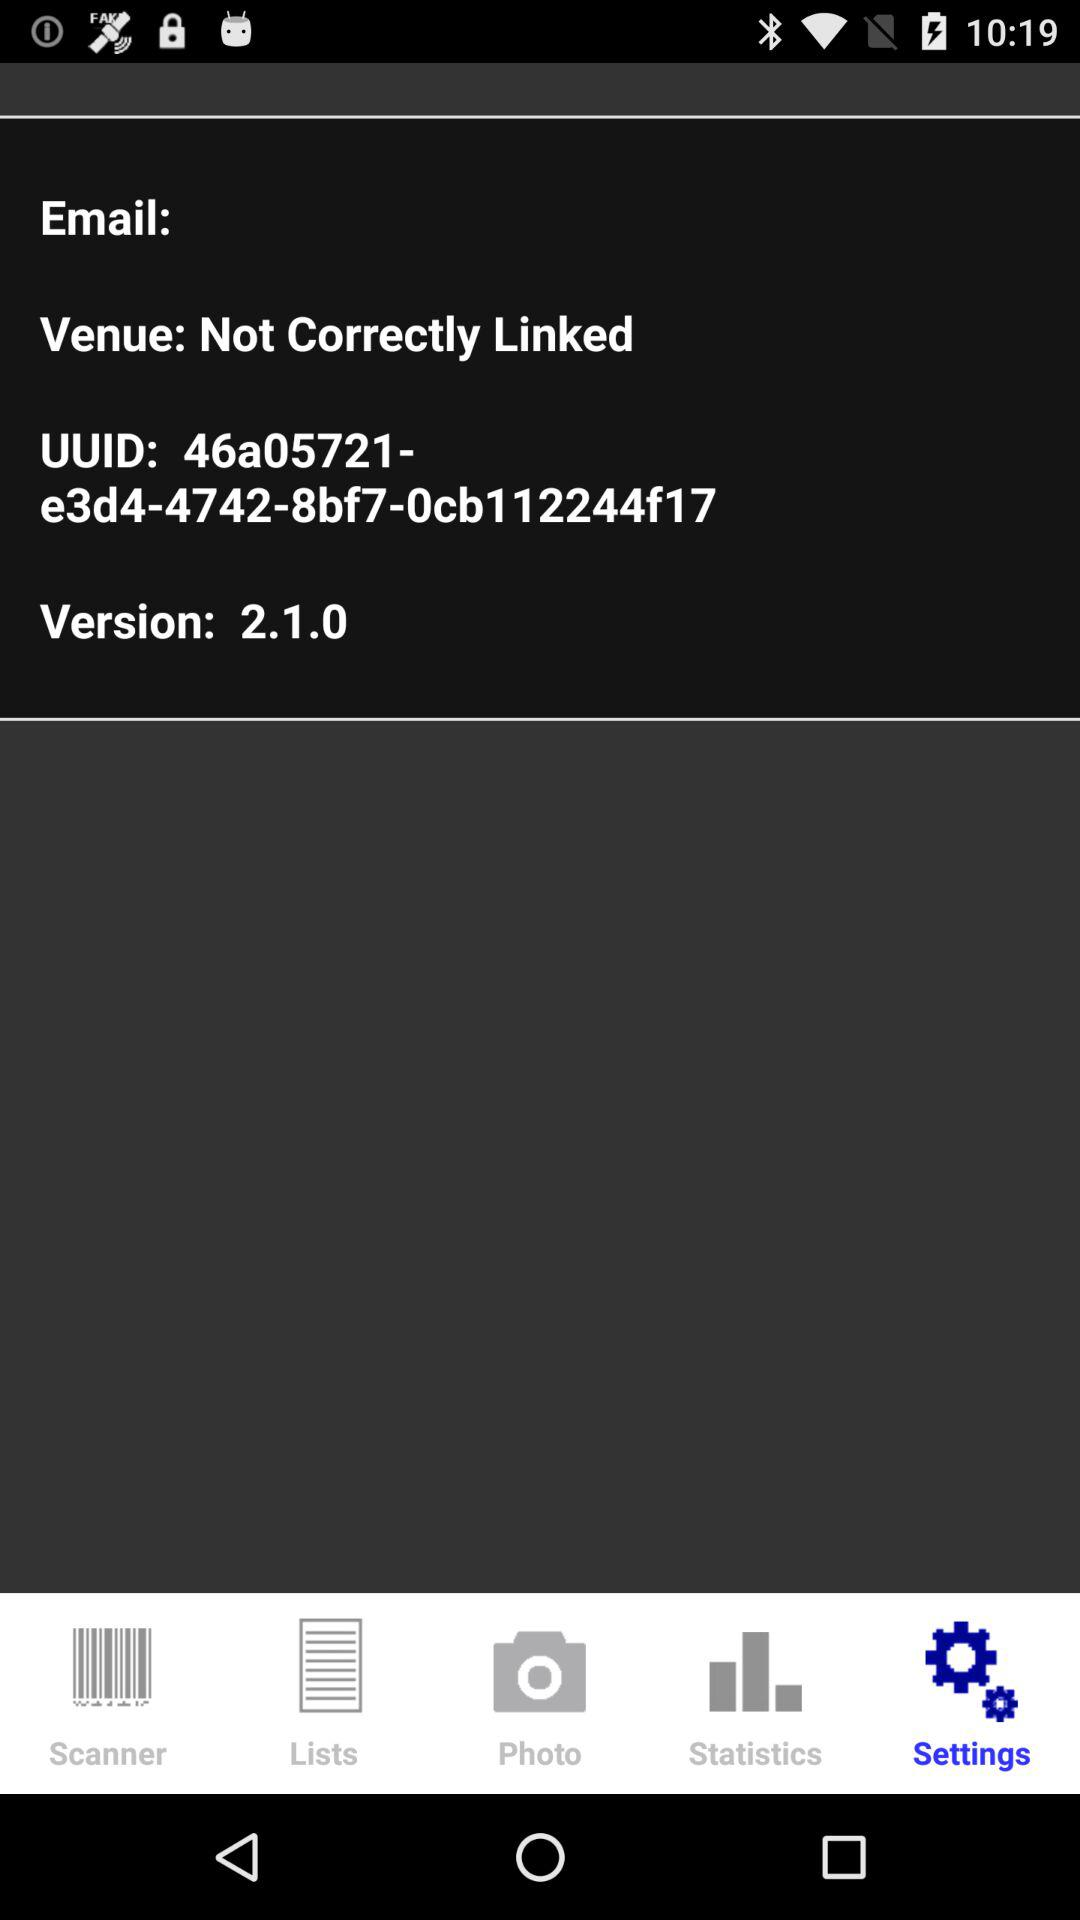What version is shown? The shown version is 2.1.0. 